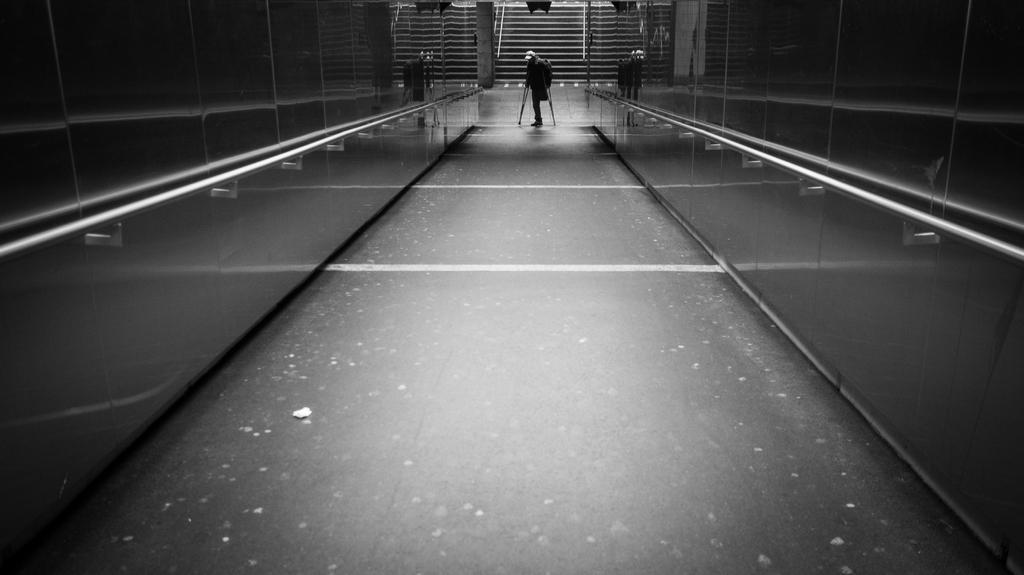How would you summarize this image in a sentence or two? In this picture there is a person on the floor and holding crutches and we can see walls with metal surface and rods. In the background of the image we can see steps. 